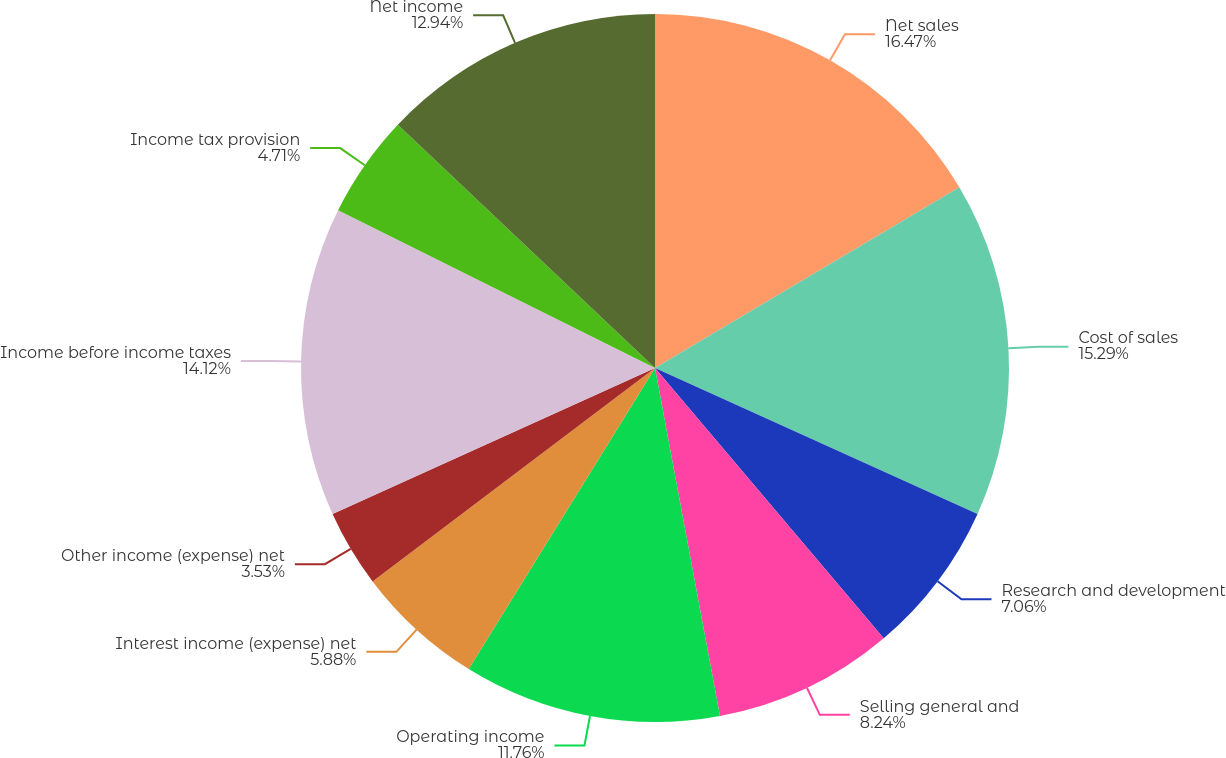Convert chart to OTSL. <chart><loc_0><loc_0><loc_500><loc_500><pie_chart><fcel>Net sales<fcel>Cost of sales<fcel>Research and development<fcel>Selling general and<fcel>Operating income<fcel>Interest income (expense) net<fcel>Other income (expense) net<fcel>Income before income taxes<fcel>Income tax provision<fcel>Net income<nl><fcel>16.47%<fcel>15.29%<fcel>7.06%<fcel>8.24%<fcel>11.76%<fcel>5.88%<fcel>3.53%<fcel>14.12%<fcel>4.71%<fcel>12.94%<nl></chart> 